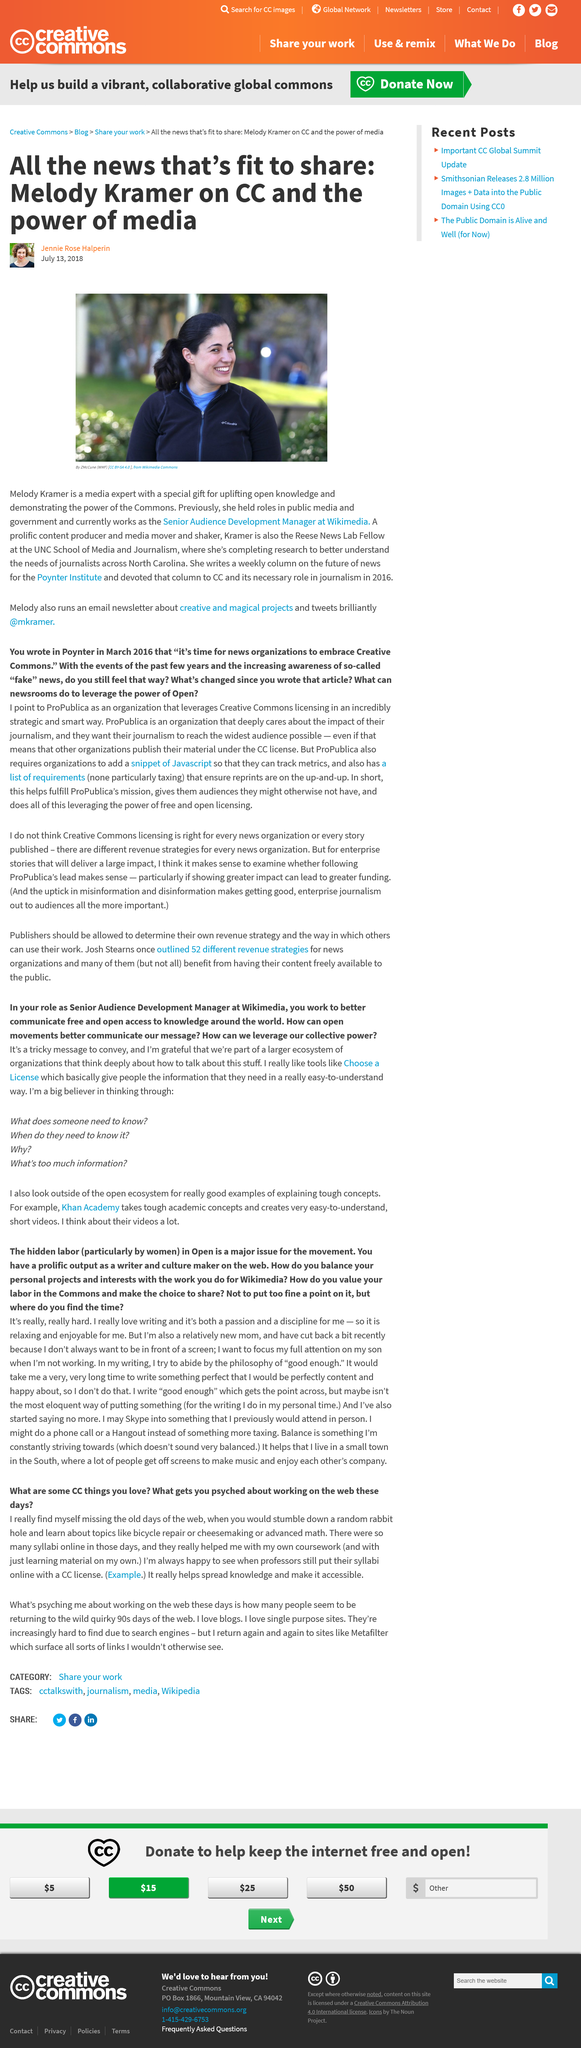Highlight a few significant elements in this photo. Melody Kramer is an expert in media, with extensive knowledge and experience in the field. The speaker is informing the audience that the person being referred to is currently employed as a Senior Audience Development Manager. The speaker inquires about the frequency of a column that is written by someone named "her." They want to know if the column is released on a weekly basis. 